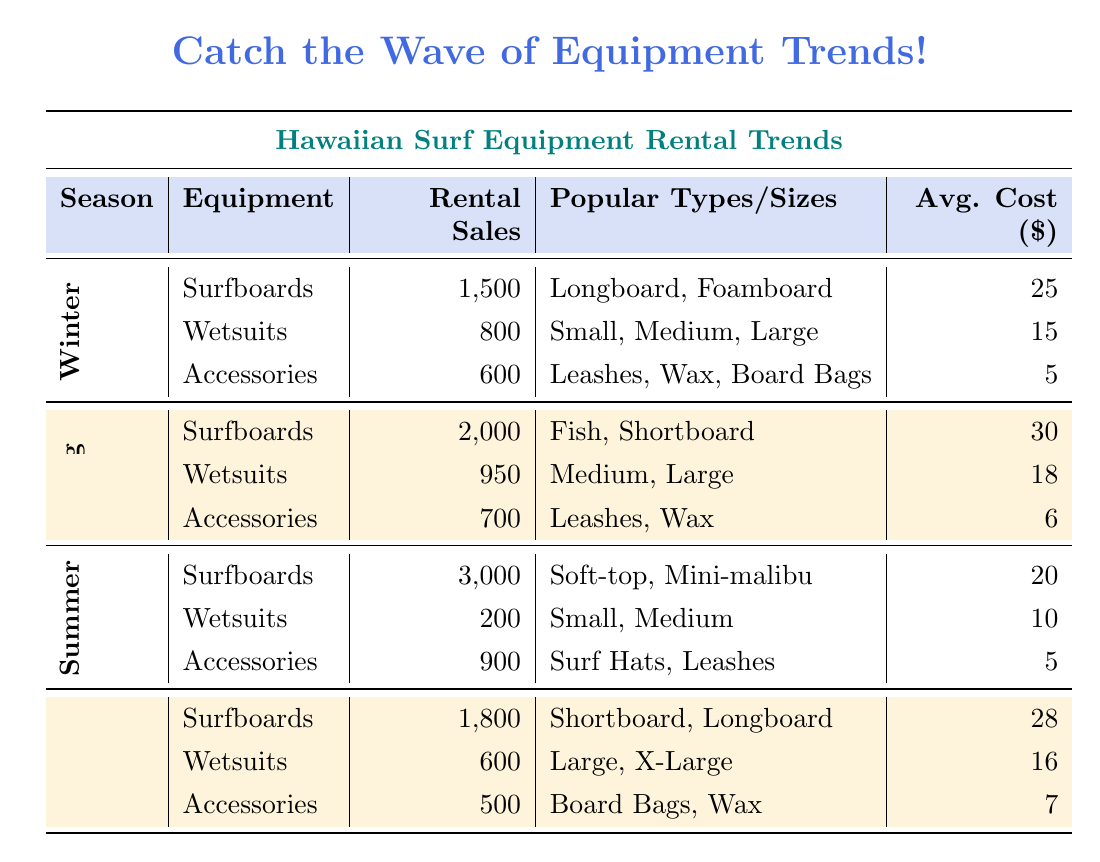What are the total rental sales for surfboards in Summer? The rental sales for surfboards in Summer is 3000 as specified in the table under the Summer season.
Answer: 3000 What is the average rental cost for wetsuits in Winter? The average rental cost for wetsuits in Winter is listed as 15 in the table.
Answer: 15 Which season had the highest rental sales for accessories? Looking at the table, the accessory rental sales in Summer were 900, which is higher than the sales in Winter (600), Spring (700), and Fall (500). Therefore, Summer had the highest rental sales for accessories.
Answer: Summer What is the total rental sales for wetsuits across all seasons? Summing the rental sales for wetsuits in all seasons: Winter (800) + Spring (950) + Summer (200) + Fall (600) = 2550.
Answer: 2550 Are there any accessories that were popular in the Winter season? Yes, the popular accessories in Winter were leashes, wax, and board bags as specified in the table.
Answer: Yes What is the average rental cost of surfboards during Spring and Fall? The average rental costs are 30 for Spring and 28 for Fall. To find the average: (30 + 28) / 2 = 29.
Answer: 29 Which type of equipment had the lowest rental sales in Summer? In Summer, wetsuits had the lowest rental sales with only 200, compared to surfboards (3000) and accessories (900).
Answer: Wetsuits Which season had the highest average rental cost for accessories? The average rental costs for accessories are Winter (5), Spring (6), Summer (5), and Fall (7). Fall had the highest average rental cost at 7.
Answer: Fall What is the difference in rental sales between surfboards in Winter and Fall? The rental sales for surfboards in Winter is 1500 and in Fall is 1800, the difference is 1800 - 1500 = 300.
Answer: 300 